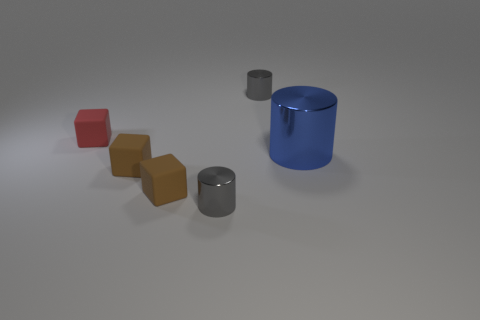Imagine these objects were designed as part of a game, what could be their function? Envisioning these objects as part of a game, they could serve various purposes. The cylinders might work as containers or goals to deposit items into, while the different sizes of the brown blocks suggest they could be a form of modular puzzle pieces. The small red block could function as a player token or key component to activate mechanisms within the game. 